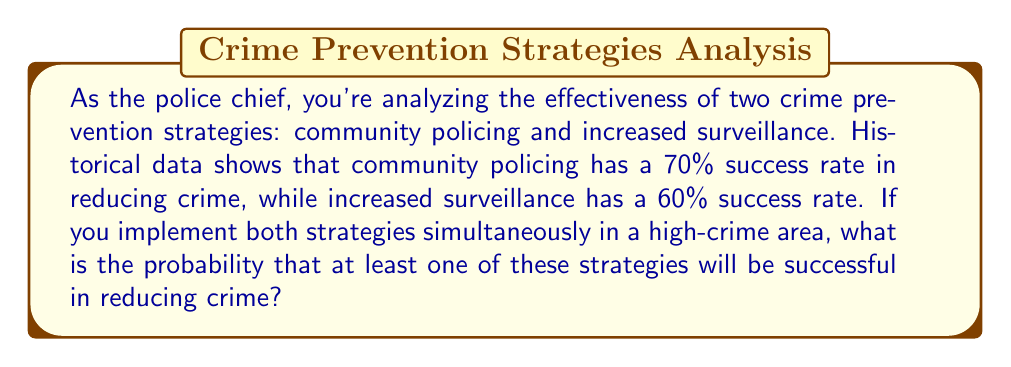What is the answer to this math problem? To solve this problem, we need to use the concept of probability of the union of events. Let's approach this step-by-step:

1) Let's define our events:
   A = Community policing is successful
   B = Increased surveillance is successful

2) We're given:
   P(A) = 0.70 (70% success rate for community policing)
   P(B) = 0.60 (60% success rate for increased surveillance)

3) We want to find P(A ∪ B), which is the probability that at least one strategy is successful.

4) The formula for the probability of the union of two events is:
   P(A ∪ B) = P(A) + P(B) - P(A ∩ B)

5) We know P(A) and P(B), but we don't know P(A ∩ B). However, if we assume the events are independent (the success of one strategy doesn't affect the other), we can calculate it:
   P(A ∩ B) = P(A) × P(B) = 0.70 × 0.60 = 0.42

6) Now we can plug everything into our formula:
   P(A ∪ B) = P(A) + P(B) - P(A ∩ B)
             = 0.70 + 0.60 - 0.42
             = 1.30 - 0.42
             = 0.88

7) Therefore, the probability that at least one strategy will be successful is 0.88 or 88%.

This result suggests a high likelihood of success when implementing both strategies simultaneously, which is valuable information for a police chief making decisions about resource allocation and crime prevention approaches.
Answer: The probability that at least one of these strategies will be successful in reducing crime is 0.88 or 88%. 